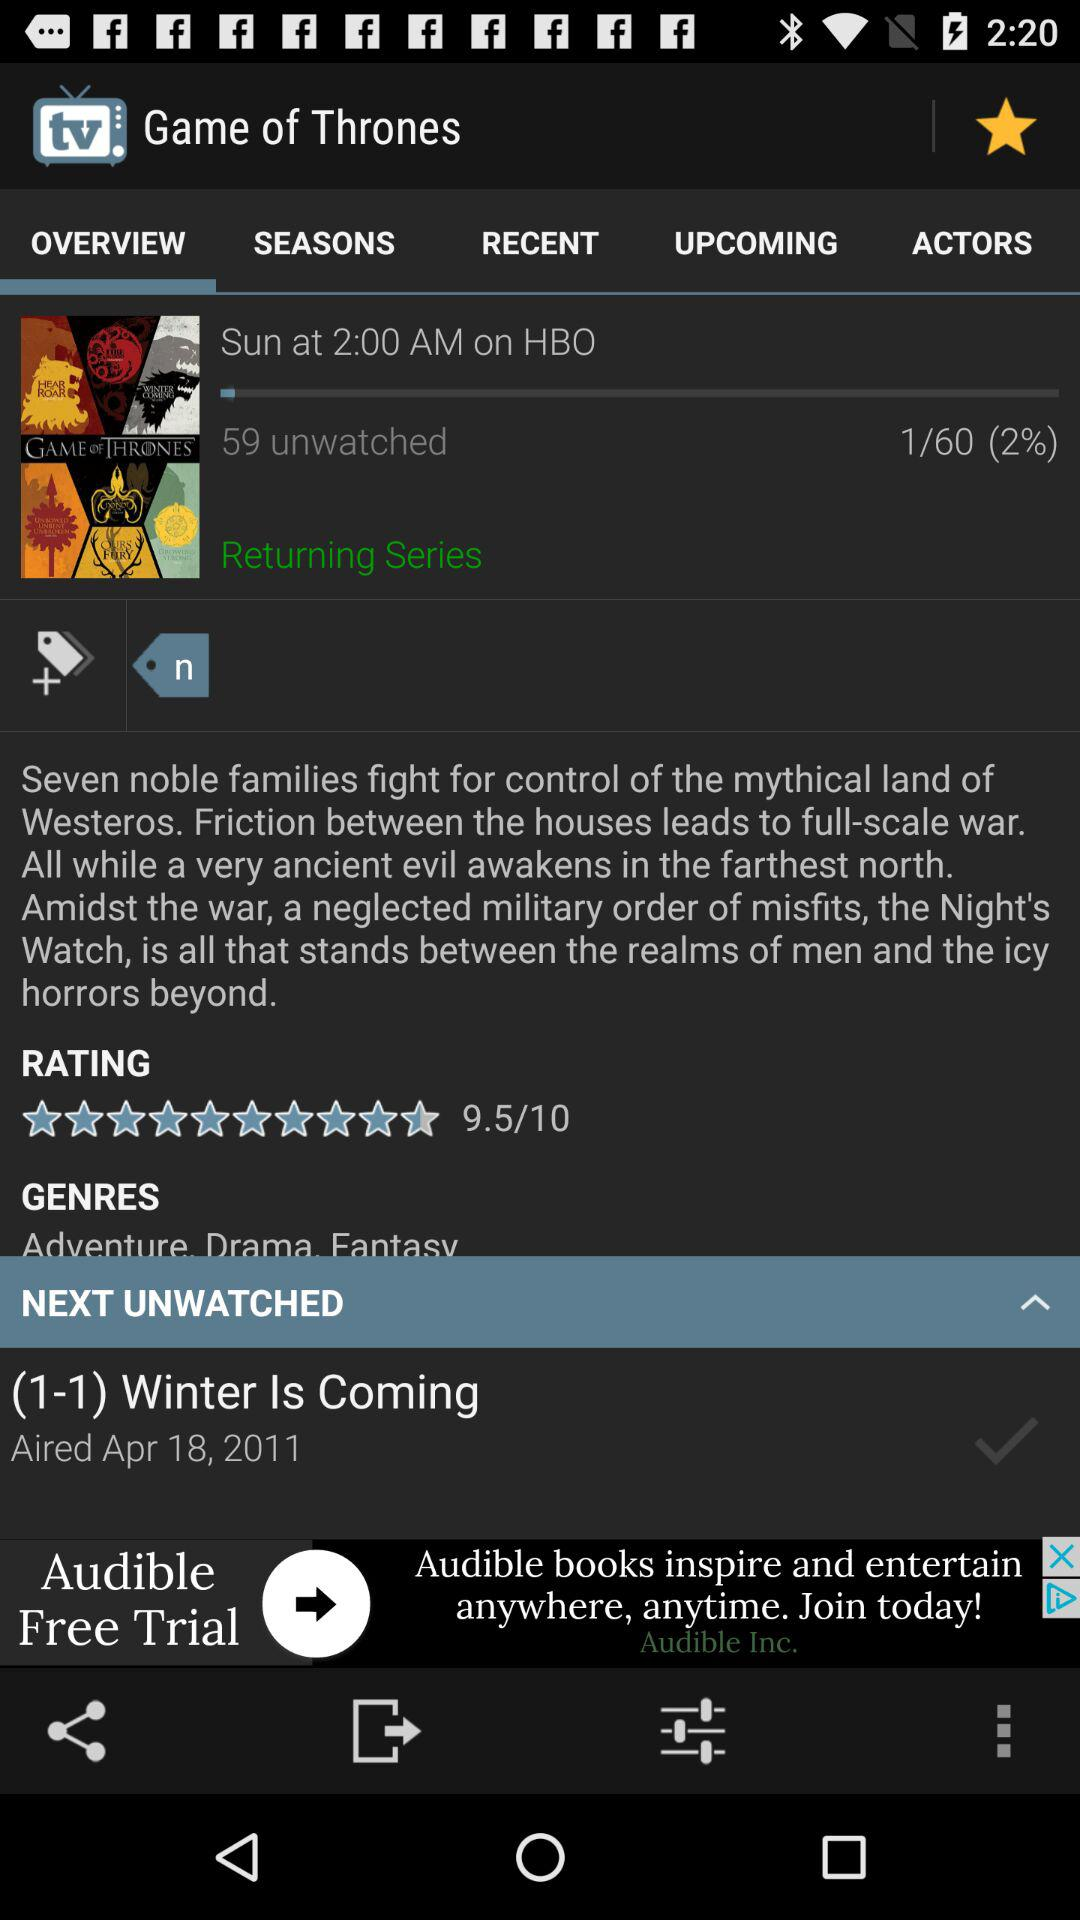How many episodes does the "Game of Thrones" series have? The "Game of Thrones" series has 60 episodes. 